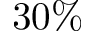<formula> <loc_0><loc_0><loc_500><loc_500>3 0 \%</formula> 